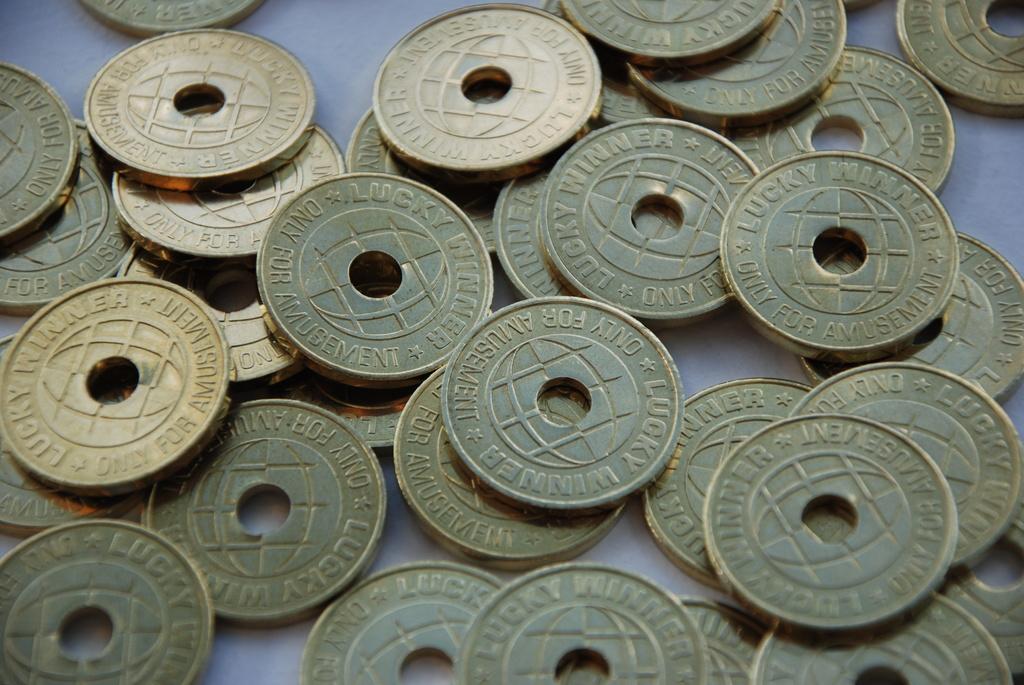What are the coins used for?
Give a very brief answer. Amusement. 